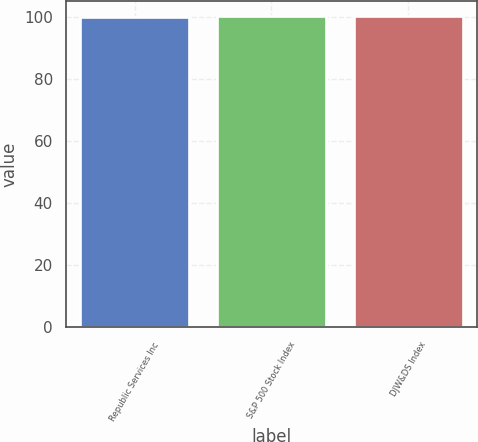Convert chart. <chart><loc_0><loc_0><loc_500><loc_500><bar_chart><fcel>Republic Services Inc<fcel>S&P 500 Stock Index<fcel>DJW&DS Index<nl><fcel>100<fcel>100.1<fcel>100.2<nl></chart> 